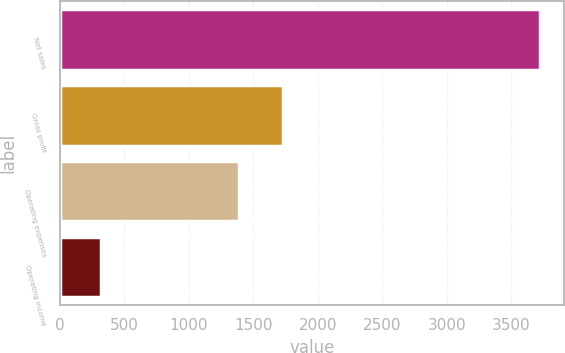Convert chart. <chart><loc_0><loc_0><loc_500><loc_500><bar_chart><fcel>Net sales<fcel>Gross profit<fcel>Operating expenses<fcel>Operating income<nl><fcel>3722<fcel>1728<fcel>1388<fcel>322<nl></chart> 